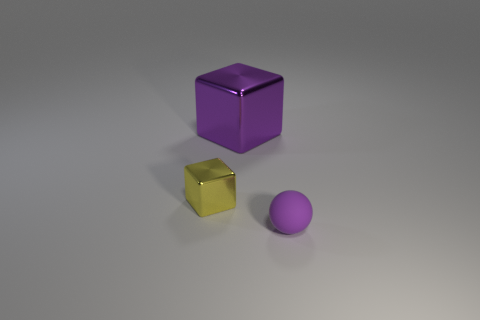How many metal objects are both to the right of the tiny metal block and left of the big purple object?
Ensure brevity in your answer.  0. Are there any big purple shiny blocks right of the object in front of the small thing that is on the left side of the tiny purple rubber ball?
Offer a terse response. No. What is the shape of the matte object that is the same size as the yellow block?
Make the answer very short. Sphere. Is there a tiny metallic thing that has the same color as the ball?
Provide a short and direct response. No. Do the small shiny object and the small purple object have the same shape?
Make the answer very short. No. What number of large objects are green matte blocks or purple rubber things?
Keep it short and to the point. 0. What color is the large cube that is made of the same material as the yellow thing?
Ensure brevity in your answer.  Purple. How many purple blocks are made of the same material as the big purple thing?
Ensure brevity in your answer.  0. There is a cube that is behind the small yellow metal thing; is its size the same as the object that is on the right side of the purple metal object?
Ensure brevity in your answer.  No. There is a purple thing that is in front of the purple thing behind the rubber sphere; what is it made of?
Provide a succinct answer. Rubber. 